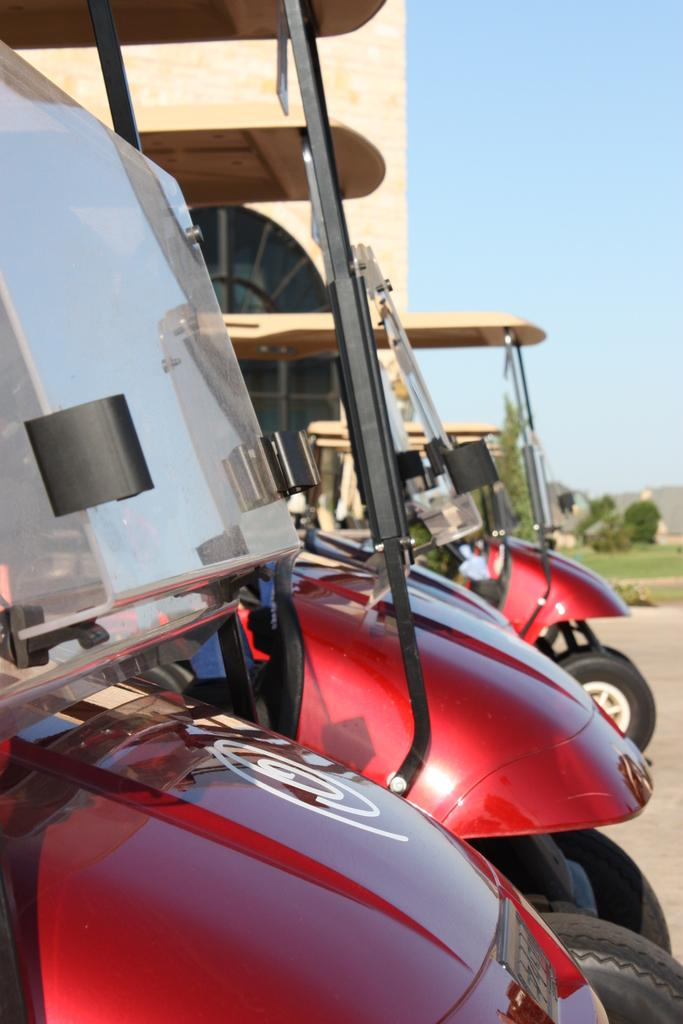What can be seen in the image that moves or transports people or goods? There are vehicles in the image that move or transport people or goods. What type of structure is visible in the background of the image? There is a building in the background of the image. What type of vegetation is present in the background of the image? There are trees with green color in the background of the image. What color is the sky in the image? The sky is blue in the image. What type of heart-shaped quartz can be seen in the dirt in the image? There is no heart-shaped quartz or dirt present in the image. 